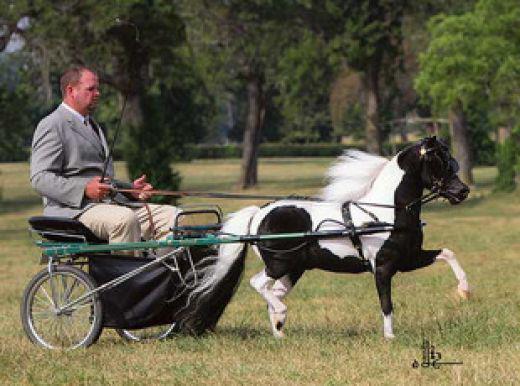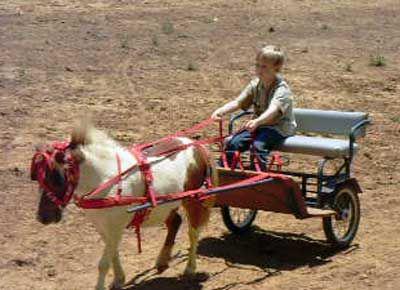The first image is the image on the left, the second image is the image on the right. Considering the images on both sides, is "there is at least one pony pulling a cart, there is a man in a blue tshirt and a cowboy hat sitting" valid? Answer yes or no. No. 